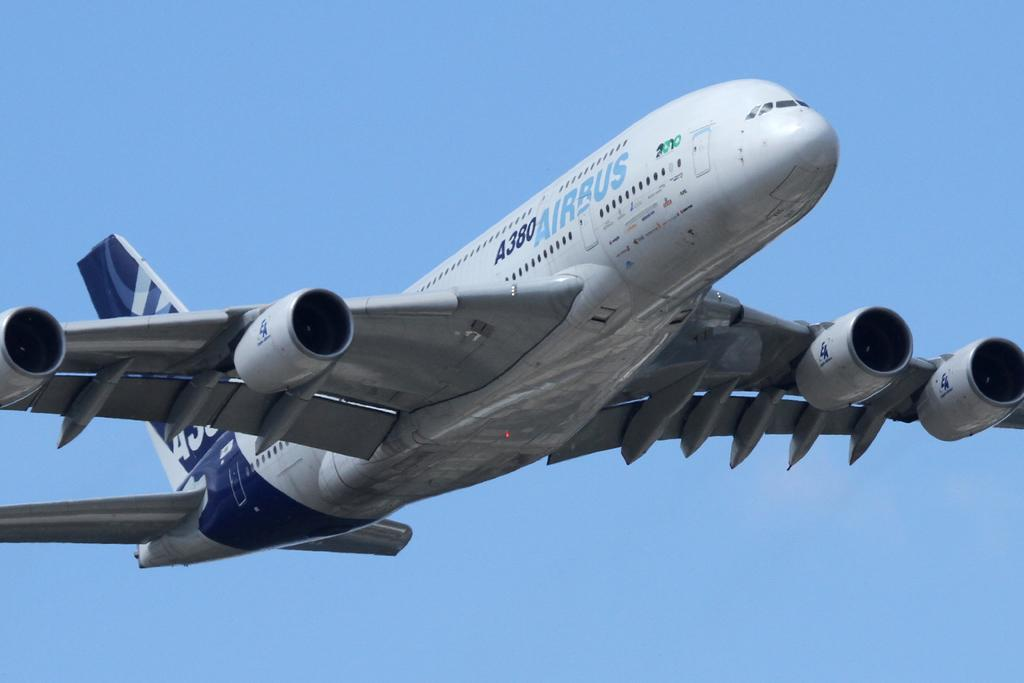Provide a one-sentence caption for the provided image. a huge Airbus plane is flying through the sky. 